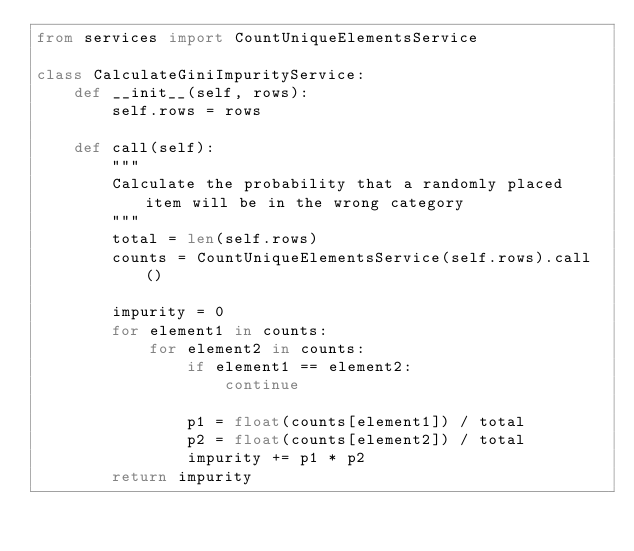<code> <loc_0><loc_0><loc_500><loc_500><_Python_>from services import CountUniqueElementsService

class CalculateGiniImpurityService:
    def __init__(self, rows):
        self.rows = rows

    def call(self):
        """
        Calculate the probability that a randomly placed item will be in the wrong category
        """
        total = len(self.rows)
        counts = CountUniqueElementsService(self.rows).call()

        impurity = 0
        for element1 in counts:
            for element2 in counts:
                if element1 == element2:
                    continue

                p1 = float(counts[element1]) / total
                p2 = float(counts[element2]) / total
                impurity += p1 * p2
        return impurity
</code> 